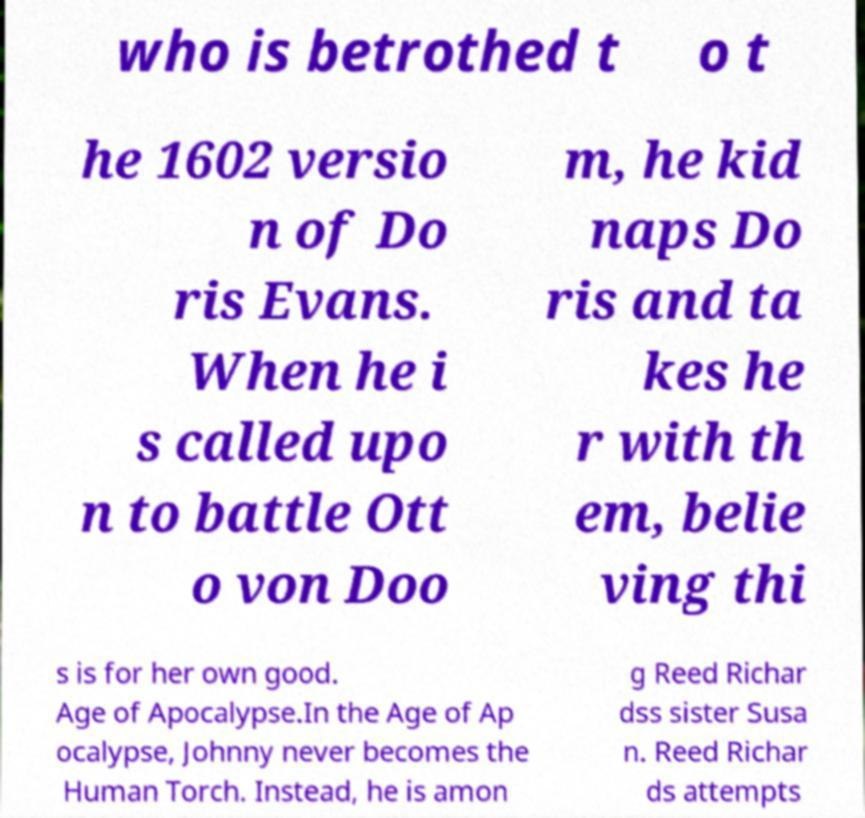Could you assist in decoding the text presented in this image and type it out clearly? who is betrothed t o t he 1602 versio n of Do ris Evans. When he i s called upo n to battle Ott o von Doo m, he kid naps Do ris and ta kes he r with th em, belie ving thi s is for her own good. Age of Apocalypse.In the Age of Ap ocalypse, Johnny never becomes the Human Torch. Instead, he is amon g Reed Richar dss sister Susa n. Reed Richar ds attempts 